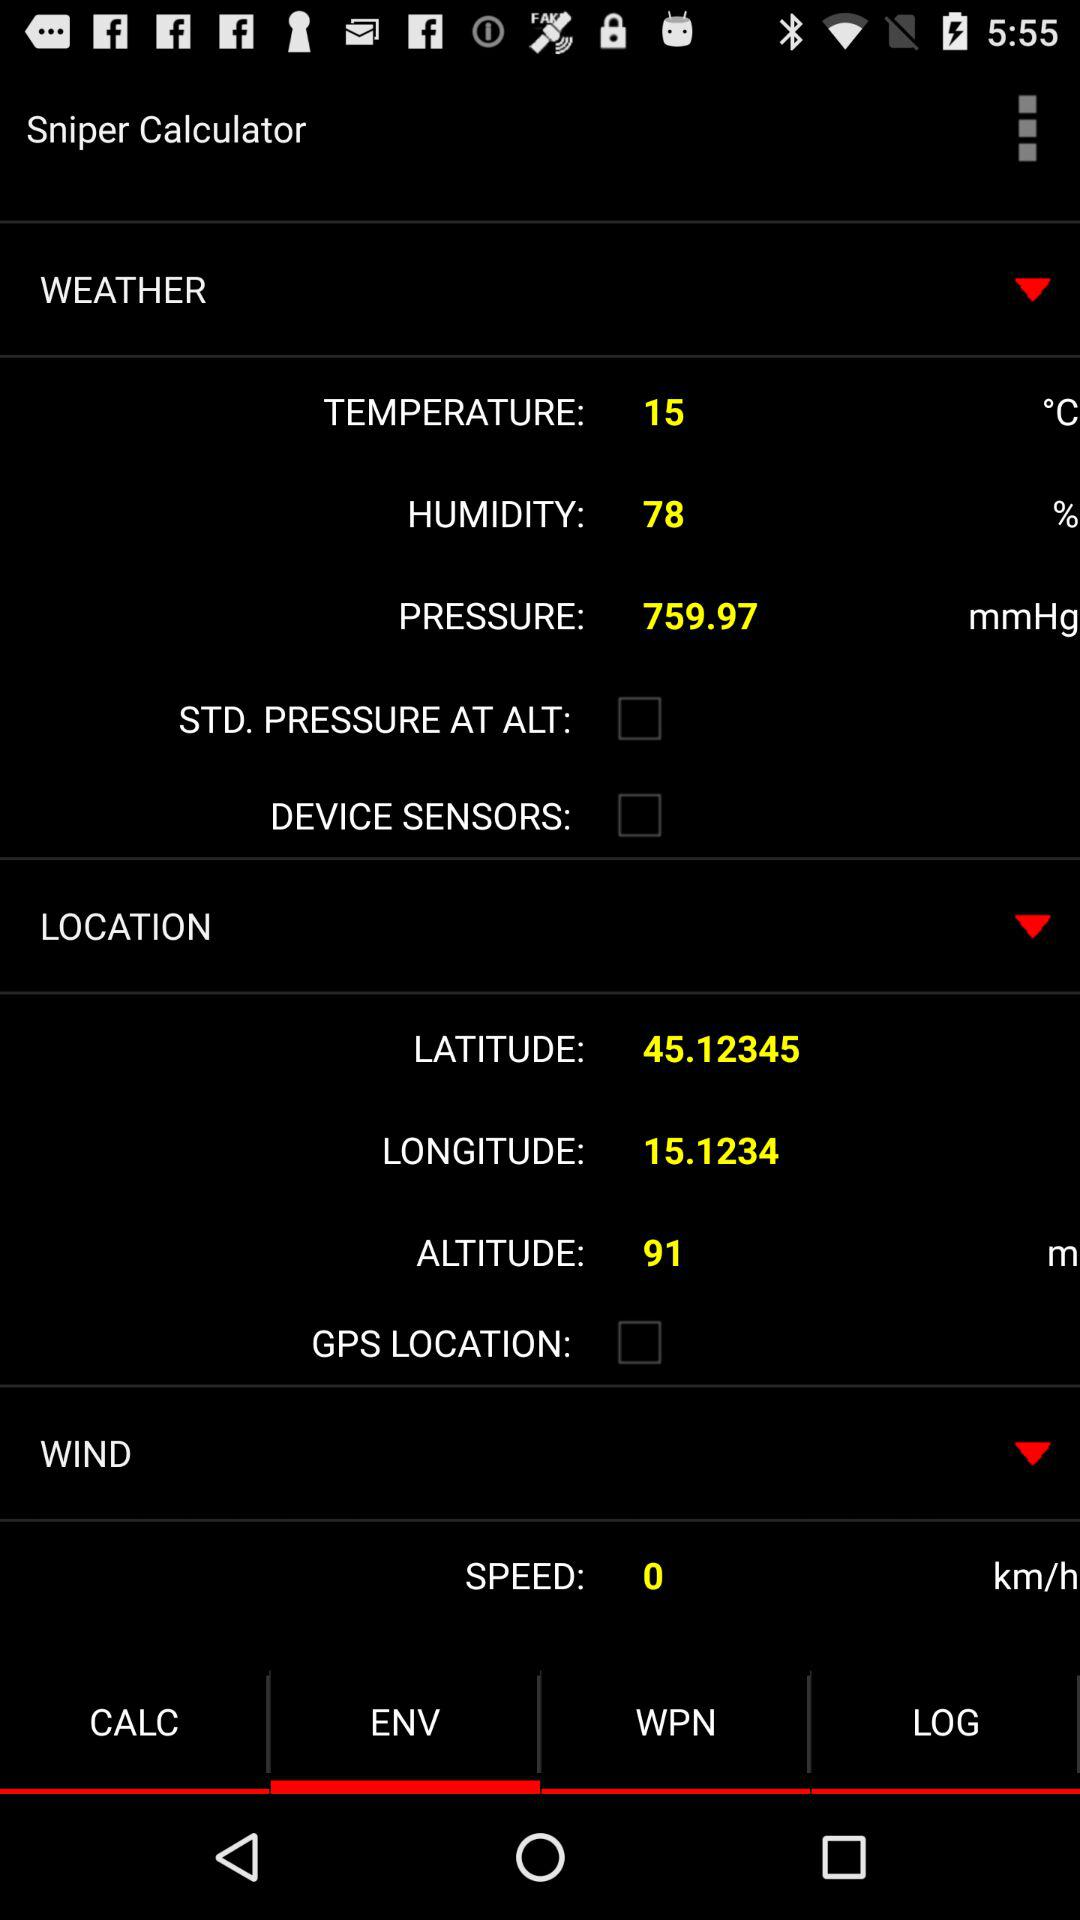What is the altitude? The altitude is 91 meters. 